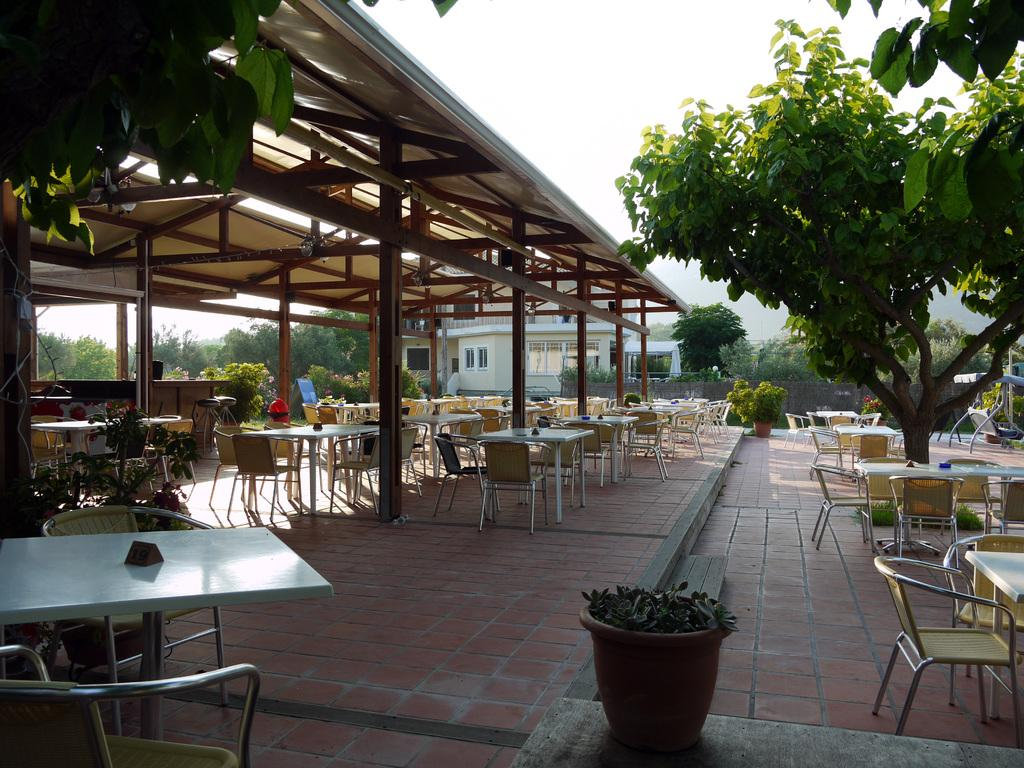What type of furniture can be seen in the image? There are chairs and tables in the image. What type of natural elements are present in the image? There are trees in the image. What type of structure is visible in the image? There is a house in the image. What type of guitar is being played in the image? There is no guitar present in the image. What type of instrument is being used to perform addition in the image? There is no instrument or addition being performed in the image. 